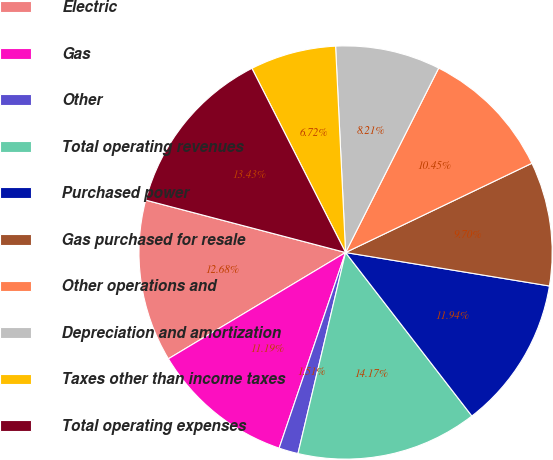Convert chart to OTSL. <chart><loc_0><loc_0><loc_500><loc_500><pie_chart><fcel>Electric<fcel>Gas<fcel>Other<fcel>Total operating revenues<fcel>Purchased power<fcel>Gas purchased for resale<fcel>Other operations and<fcel>Depreciation and amortization<fcel>Taxes other than income taxes<fcel>Total operating expenses<nl><fcel>12.68%<fcel>11.19%<fcel>1.51%<fcel>14.17%<fcel>11.94%<fcel>9.7%<fcel>10.45%<fcel>8.21%<fcel>6.72%<fcel>13.43%<nl></chart> 